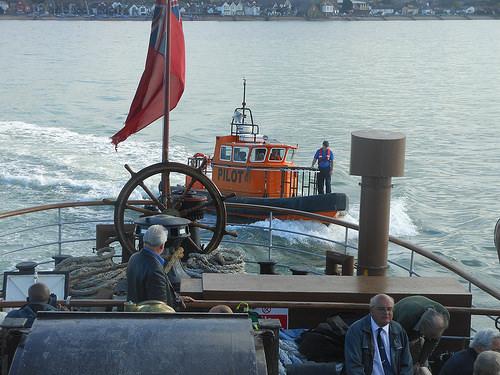<image>
Can you confirm if the flag is on the boat? No. The flag is not positioned on the boat. They may be near each other, but the flag is not supported by or resting on top of the boat. Is there a man to the left of the wheel? No. The man is not to the left of the wheel. From this viewpoint, they have a different horizontal relationship. Where is the flag in relation to the boat? Is it above the boat? No. The flag is not positioned above the boat. The vertical arrangement shows a different relationship. 